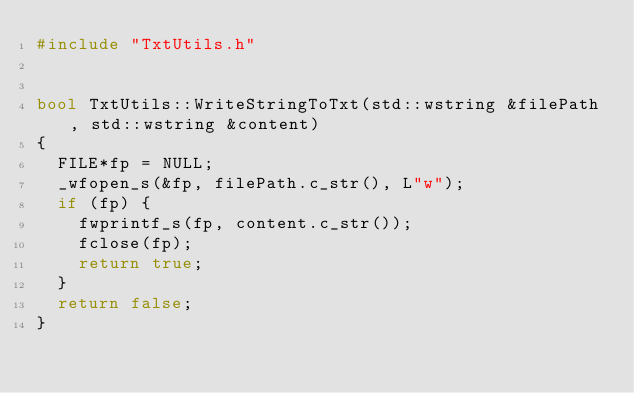Convert code to text. <code><loc_0><loc_0><loc_500><loc_500><_C++_>#include "TxtUtils.h"


bool TxtUtils::WriteStringToTxt(std::wstring &filePath, std::wstring &content)
{
	FILE*fp = NULL;
	_wfopen_s(&fp, filePath.c_str(), L"w");
	if (fp) {
		fwprintf_s(fp, content.c_str());
		fclose(fp);
		return true;
	}
	return false;
}
</code> 